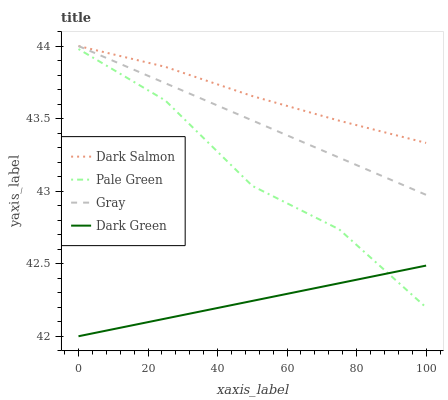Does Dark Green have the minimum area under the curve?
Answer yes or no. Yes. Does Dark Salmon have the maximum area under the curve?
Answer yes or no. Yes. Does Pale Green have the minimum area under the curve?
Answer yes or no. No. Does Pale Green have the maximum area under the curve?
Answer yes or no. No. Is Dark Green the smoothest?
Answer yes or no. Yes. Is Pale Green the roughest?
Answer yes or no. Yes. Is Dark Salmon the smoothest?
Answer yes or no. No. Is Dark Salmon the roughest?
Answer yes or no. No. Does Dark Green have the lowest value?
Answer yes or no. Yes. Does Pale Green have the lowest value?
Answer yes or no. No. Does Dark Salmon have the highest value?
Answer yes or no. Yes. Does Pale Green have the highest value?
Answer yes or no. No. Is Dark Green less than Gray?
Answer yes or no. Yes. Is Gray greater than Dark Green?
Answer yes or no. Yes. Does Dark Salmon intersect Gray?
Answer yes or no. Yes. Is Dark Salmon less than Gray?
Answer yes or no. No. Is Dark Salmon greater than Gray?
Answer yes or no. No. Does Dark Green intersect Gray?
Answer yes or no. No. 